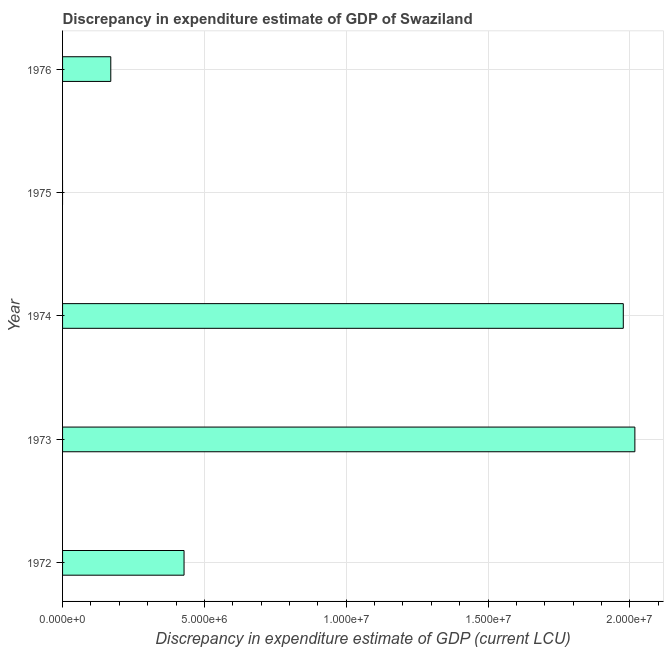What is the title of the graph?
Provide a succinct answer. Discrepancy in expenditure estimate of GDP of Swaziland. What is the label or title of the X-axis?
Your response must be concise. Discrepancy in expenditure estimate of GDP (current LCU). What is the label or title of the Y-axis?
Offer a terse response. Year. What is the discrepancy in expenditure estimate of gdp in 1972?
Ensure brevity in your answer.  4.28e+06. Across all years, what is the maximum discrepancy in expenditure estimate of gdp?
Your answer should be compact. 2.02e+07. In which year was the discrepancy in expenditure estimate of gdp maximum?
Make the answer very short. 1973. What is the sum of the discrepancy in expenditure estimate of gdp?
Keep it short and to the point. 4.59e+07. What is the difference between the discrepancy in expenditure estimate of gdp in 1974 and 1976?
Your answer should be compact. 1.81e+07. What is the average discrepancy in expenditure estimate of gdp per year?
Give a very brief answer. 9.19e+06. What is the median discrepancy in expenditure estimate of gdp?
Give a very brief answer. 4.28e+06. In how many years, is the discrepancy in expenditure estimate of gdp greater than 1000000 LCU?
Give a very brief answer. 4. What is the ratio of the discrepancy in expenditure estimate of gdp in 1973 to that in 1976?
Your answer should be compact. 11.87. Is the discrepancy in expenditure estimate of gdp in 1974 less than that in 1976?
Your answer should be very brief. No. What is the difference between the highest and the second highest discrepancy in expenditure estimate of gdp?
Your answer should be very brief. 4.08e+05. Is the sum of the discrepancy in expenditure estimate of gdp in 1973 and 1974 greater than the maximum discrepancy in expenditure estimate of gdp across all years?
Provide a succinct answer. Yes. What is the difference between the highest and the lowest discrepancy in expenditure estimate of gdp?
Provide a short and direct response. 2.02e+07. In how many years, is the discrepancy in expenditure estimate of gdp greater than the average discrepancy in expenditure estimate of gdp taken over all years?
Offer a terse response. 2. How many years are there in the graph?
Ensure brevity in your answer.  5. What is the difference between two consecutive major ticks on the X-axis?
Give a very brief answer. 5.00e+06. Are the values on the major ticks of X-axis written in scientific E-notation?
Ensure brevity in your answer.  Yes. What is the Discrepancy in expenditure estimate of GDP (current LCU) of 1972?
Your response must be concise. 4.28e+06. What is the Discrepancy in expenditure estimate of GDP (current LCU) in 1973?
Ensure brevity in your answer.  2.02e+07. What is the Discrepancy in expenditure estimate of GDP (current LCU) of 1974?
Give a very brief answer. 1.98e+07. What is the Discrepancy in expenditure estimate of GDP (current LCU) of 1976?
Offer a very short reply. 1.70e+06. What is the difference between the Discrepancy in expenditure estimate of GDP (current LCU) in 1972 and 1973?
Offer a very short reply. -1.59e+07. What is the difference between the Discrepancy in expenditure estimate of GDP (current LCU) in 1972 and 1974?
Provide a short and direct response. -1.55e+07. What is the difference between the Discrepancy in expenditure estimate of GDP (current LCU) in 1972 and 1976?
Your response must be concise. 2.58e+06. What is the difference between the Discrepancy in expenditure estimate of GDP (current LCU) in 1973 and 1974?
Your answer should be very brief. 4.08e+05. What is the difference between the Discrepancy in expenditure estimate of GDP (current LCU) in 1973 and 1976?
Your response must be concise. 1.85e+07. What is the difference between the Discrepancy in expenditure estimate of GDP (current LCU) in 1974 and 1976?
Keep it short and to the point. 1.81e+07. What is the ratio of the Discrepancy in expenditure estimate of GDP (current LCU) in 1972 to that in 1973?
Provide a short and direct response. 0.21. What is the ratio of the Discrepancy in expenditure estimate of GDP (current LCU) in 1972 to that in 1974?
Provide a succinct answer. 0.22. What is the ratio of the Discrepancy in expenditure estimate of GDP (current LCU) in 1972 to that in 1976?
Ensure brevity in your answer.  2.52. What is the ratio of the Discrepancy in expenditure estimate of GDP (current LCU) in 1973 to that in 1976?
Make the answer very short. 11.87. What is the ratio of the Discrepancy in expenditure estimate of GDP (current LCU) in 1974 to that in 1976?
Provide a short and direct response. 11.63. 